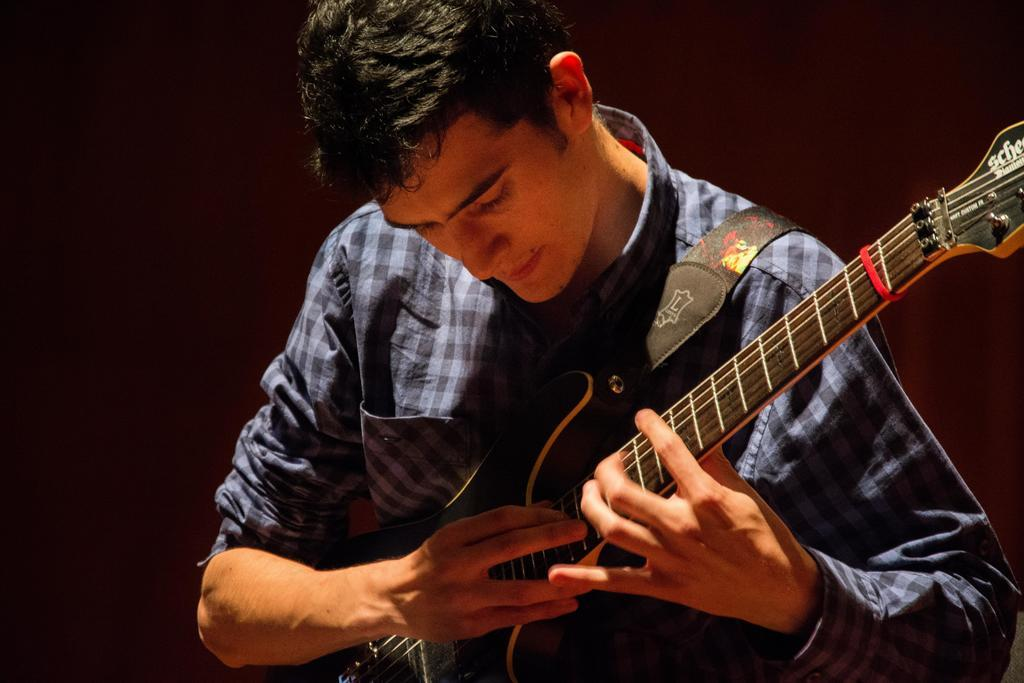What is the main subject of the image? There is a person in the image. What is the person doing in the image? The person is playing a guitar. What type of fire can be seen in the image? There is no fire present in the image. What is the person's occupation as a carpenter in the image? The image does not depict the person as a carpenter, nor does it show any carpentry-related activities. How does the person feel while playing the guitar in the image? The image does not convey the person's emotions or feelings while playing the guitar. 